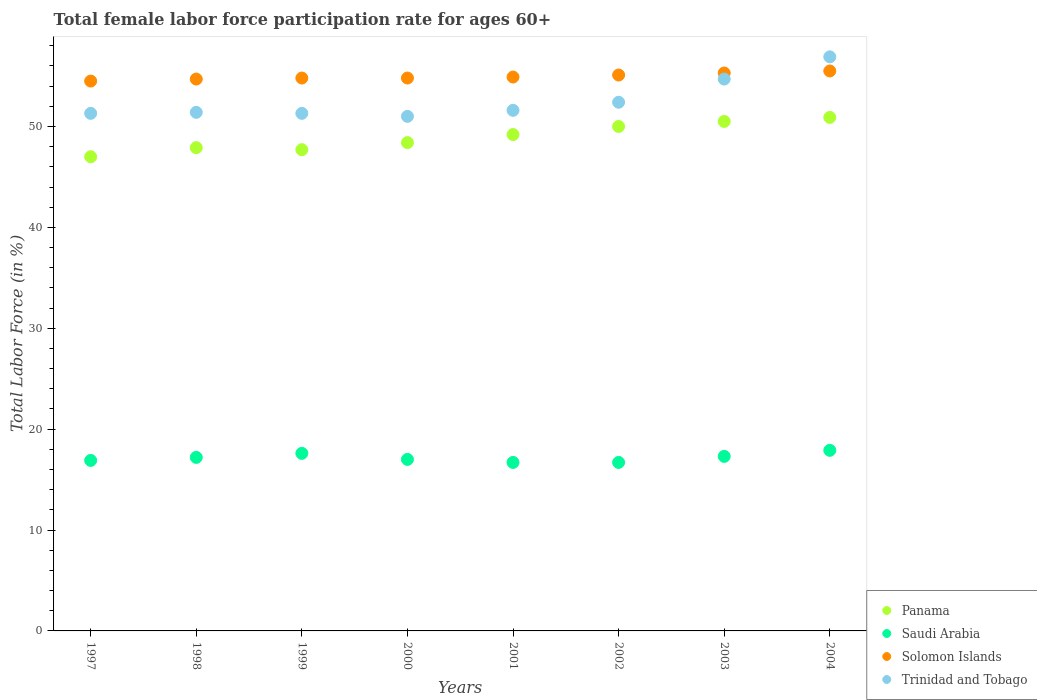Is the number of dotlines equal to the number of legend labels?
Your answer should be compact. Yes. What is the female labor force participation rate in Trinidad and Tobago in 1998?
Your response must be concise. 51.4. Across all years, what is the maximum female labor force participation rate in Saudi Arabia?
Give a very brief answer. 17.9. Across all years, what is the minimum female labor force participation rate in Panama?
Provide a succinct answer. 47. In which year was the female labor force participation rate in Trinidad and Tobago maximum?
Offer a terse response. 2004. What is the total female labor force participation rate in Solomon Islands in the graph?
Make the answer very short. 439.6. What is the difference between the female labor force participation rate in Saudi Arabia in 1999 and that in 2000?
Keep it short and to the point. 0.6. What is the difference between the female labor force participation rate in Panama in 2002 and the female labor force participation rate in Trinidad and Tobago in 1999?
Your answer should be very brief. -1.3. What is the average female labor force participation rate in Saudi Arabia per year?
Give a very brief answer. 17.16. In the year 2002, what is the difference between the female labor force participation rate in Trinidad and Tobago and female labor force participation rate in Solomon Islands?
Your answer should be compact. -2.7. In how many years, is the female labor force participation rate in Saudi Arabia greater than 54 %?
Offer a very short reply. 0. What is the ratio of the female labor force participation rate in Solomon Islands in 1999 to that in 2004?
Your answer should be very brief. 0.99. Is the female labor force participation rate in Panama in 2000 less than that in 2003?
Your answer should be very brief. Yes. Is the difference between the female labor force participation rate in Trinidad and Tobago in 2001 and 2004 greater than the difference between the female labor force participation rate in Solomon Islands in 2001 and 2004?
Make the answer very short. No. What is the difference between the highest and the second highest female labor force participation rate in Saudi Arabia?
Offer a very short reply. 0.3. What is the difference between the highest and the lowest female labor force participation rate in Panama?
Your answer should be very brief. 3.9. In how many years, is the female labor force participation rate in Panama greater than the average female labor force participation rate in Panama taken over all years?
Ensure brevity in your answer.  4. Is the sum of the female labor force participation rate in Trinidad and Tobago in 1999 and 2002 greater than the maximum female labor force participation rate in Solomon Islands across all years?
Offer a very short reply. Yes. Is it the case that in every year, the sum of the female labor force participation rate in Panama and female labor force participation rate in Saudi Arabia  is greater than the sum of female labor force participation rate in Solomon Islands and female labor force participation rate in Trinidad and Tobago?
Offer a terse response. No. Does the female labor force participation rate in Solomon Islands monotonically increase over the years?
Ensure brevity in your answer.  No. Is the female labor force participation rate in Trinidad and Tobago strictly less than the female labor force participation rate in Panama over the years?
Provide a short and direct response. No. What is the difference between two consecutive major ticks on the Y-axis?
Your answer should be very brief. 10. Are the values on the major ticks of Y-axis written in scientific E-notation?
Provide a short and direct response. No. Does the graph contain any zero values?
Provide a succinct answer. No. Does the graph contain grids?
Your answer should be compact. No. How many legend labels are there?
Provide a succinct answer. 4. What is the title of the graph?
Give a very brief answer. Total female labor force participation rate for ages 60+. What is the Total Labor Force (in %) in Panama in 1997?
Provide a short and direct response. 47. What is the Total Labor Force (in %) in Saudi Arabia in 1997?
Keep it short and to the point. 16.9. What is the Total Labor Force (in %) of Solomon Islands in 1997?
Your answer should be compact. 54.5. What is the Total Labor Force (in %) in Trinidad and Tobago in 1997?
Provide a succinct answer. 51.3. What is the Total Labor Force (in %) in Panama in 1998?
Your answer should be very brief. 47.9. What is the Total Labor Force (in %) of Saudi Arabia in 1998?
Make the answer very short. 17.2. What is the Total Labor Force (in %) of Solomon Islands in 1998?
Offer a terse response. 54.7. What is the Total Labor Force (in %) in Trinidad and Tobago in 1998?
Your answer should be very brief. 51.4. What is the Total Labor Force (in %) of Panama in 1999?
Ensure brevity in your answer.  47.7. What is the Total Labor Force (in %) of Saudi Arabia in 1999?
Ensure brevity in your answer.  17.6. What is the Total Labor Force (in %) of Solomon Islands in 1999?
Keep it short and to the point. 54.8. What is the Total Labor Force (in %) in Trinidad and Tobago in 1999?
Offer a very short reply. 51.3. What is the Total Labor Force (in %) of Panama in 2000?
Offer a terse response. 48.4. What is the Total Labor Force (in %) of Solomon Islands in 2000?
Your answer should be very brief. 54.8. What is the Total Labor Force (in %) in Trinidad and Tobago in 2000?
Provide a succinct answer. 51. What is the Total Labor Force (in %) of Panama in 2001?
Make the answer very short. 49.2. What is the Total Labor Force (in %) of Saudi Arabia in 2001?
Offer a terse response. 16.7. What is the Total Labor Force (in %) in Solomon Islands in 2001?
Ensure brevity in your answer.  54.9. What is the Total Labor Force (in %) of Trinidad and Tobago in 2001?
Your response must be concise. 51.6. What is the Total Labor Force (in %) of Panama in 2002?
Offer a very short reply. 50. What is the Total Labor Force (in %) of Saudi Arabia in 2002?
Keep it short and to the point. 16.7. What is the Total Labor Force (in %) in Solomon Islands in 2002?
Make the answer very short. 55.1. What is the Total Labor Force (in %) of Trinidad and Tobago in 2002?
Your answer should be very brief. 52.4. What is the Total Labor Force (in %) of Panama in 2003?
Your answer should be compact. 50.5. What is the Total Labor Force (in %) in Saudi Arabia in 2003?
Give a very brief answer. 17.3. What is the Total Labor Force (in %) in Solomon Islands in 2003?
Your answer should be very brief. 55.3. What is the Total Labor Force (in %) in Trinidad and Tobago in 2003?
Your answer should be compact. 54.7. What is the Total Labor Force (in %) in Panama in 2004?
Give a very brief answer. 50.9. What is the Total Labor Force (in %) of Saudi Arabia in 2004?
Offer a very short reply. 17.9. What is the Total Labor Force (in %) in Solomon Islands in 2004?
Your answer should be very brief. 55.5. What is the Total Labor Force (in %) of Trinidad and Tobago in 2004?
Provide a short and direct response. 56.9. Across all years, what is the maximum Total Labor Force (in %) of Panama?
Give a very brief answer. 50.9. Across all years, what is the maximum Total Labor Force (in %) in Saudi Arabia?
Your response must be concise. 17.9. Across all years, what is the maximum Total Labor Force (in %) of Solomon Islands?
Your answer should be compact. 55.5. Across all years, what is the maximum Total Labor Force (in %) of Trinidad and Tobago?
Your answer should be compact. 56.9. Across all years, what is the minimum Total Labor Force (in %) in Panama?
Offer a very short reply. 47. Across all years, what is the minimum Total Labor Force (in %) in Saudi Arabia?
Your answer should be very brief. 16.7. Across all years, what is the minimum Total Labor Force (in %) in Solomon Islands?
Provide a succinct answer. 54.5. Across all years, what is the minimum Total Labor Force (in %) in Trinidad and Tobago?
Provide a succinct answer. 51. What is the total Total Labor Force (in %) of Panama in the graph?
Ensure brevity in your answer.  391.6. What is the total Total Labor Force (in %) in Saudi Arabia in the graph?
Your answer should be very brief. 137.3. What is the total Total Labor Force (in %) of Solomon Islands in the graph?
Your response must be concise. 439.6. What is the total Total Labor Force (in %) of Trinidad and Tobago in the graph?
Your response must be concise. 420.6. What is the difference between the Total Labor Force (in %) of Trinidad and Tobago in 1997 and that in 1998?
Ensure brevity in your answer.  -0.1. What is the difference between the Total Labor Force (in %) in Solomon Islands in 1997 and that in 1999?
Make the answer very short. -0.3. What is the difference between the Total Labor Force (in %) of Trinidad and Tobago in 1997 and that in 1999?
Provide a short and direct response. 0. What is the difference between the Total Labor Force (in %) of Solomon Islands in 1997 and that in 2000?
Give a very brief answer. -0.3. What is the difference between the Total Labor Force (in %) of Trinidad and Tobago in 1997 and that in 2000?
Your answer should be very brief. 0.3. What is the difference between the Total Labor Force (in %) in Saudi Arabia in 1997 and that in 2001?
Your answer should be compact. 0.2. What is the difference between the Total Labor Force (in %) of Solomon Islands in 1997 and that in 2001?
Ensure brevity in your answer.  -0.4. What is the difference between the Total Labor Force (in %) in Trinidad and Tobago in 1997 and that in 2001?
Give a very brief answer. -0.3. What is the difference between the Total Labor Force (in %) of Panama in 1997 and that in 2002?
Keep it short and to the point. -3. What is the difference between the Total Labor Force (in %) of Saudi Arabia in 1997 and that in 2002?
Provide a succinct answer. 0.2. What is the difference between the Total Labor Force (in %) of Solomon Islands in 1997 and that in 2002?
Make the answer very short. -0.6. What is the difference between the Total Labor Force (in %) of Solomon Islands in 1997 and that in 2003?
Ensure brevity in your answer.  -0.8. What is the difference between the Total Labor Force (in %) of Trinidad and Tobago in 1997 and that in 2003?
Your response must be concise. -3.4. What is the difference between the Total Labor Force (in %) of Panama in 1997 and that in 2004?
Keep it short and to the point. -3.9. What is the difference between the Total Labor Force (in %) in Saudi Arabia in 1997 and that in 2004?
Provide a succinct answer. -1. What is the difference between the Total Labor Force (in %) of Solomon Islands in 1997 and that in 2004?
Give a very brief answer. -1. What is the difference between the Total Labor Force (in %) in Panama in 1998 and that in 1999?
Make the answer very short. 0.2. What is the difference between the Total Labor Force (in %) in Panama in 1998 and that in 2000?
Keep it short and to the point. -0.5. What is the difference between the Total Labor Force (in %) of Saudi Arabia in 1998 and that in 2000?
Your response must be concise. 0.2. What is the difference between the Total Labor Force (in %) of Trinidad and Tobago in 1998 and that in 2000?
Offer a very short reply. 0.4. What is the difference between the Total Labor Force (in %) in Saudi Arabia in 1998 and that in 2001?
Your response must be concise. 0.5. What is the difference between the Total Labor Force (in %) of Solomon Islands in 1998 and that in 2001?
Your answer should be very brief. -0.2. What is the difference between the Total Labor Force (in %) of Trinidad and Tobago in 1998 and that in 2001?
Offer a terse response. -0.2. What is the difference between the Total Labor Force (in %) of Solomon Islands in 1998 and that in 2002?
Your answer should be compact. -0.4. What is the difference between the Total Labor Force (in %) of Trinidad and Tobago in 1998 and that in 2002?
Ensure brevity in your answer.  -1. What is the difference between the Total Labor Force (in %) of Saudi Arabia in 1998 and that in 2003?
Provide a succinct answer. -0.1. What is the difference between the Total Labor Force (in %) in Solomon Islands in 1998 and that in 2003?
Your response must be concise. -0.6. What is the difference between the Total Labor Force (in %) in Panama in 1998 and that in 2004?
Offer a terse response. -3. What is the difference between the Total Labor Force (in %) of Saudi Arabia in 1998 and that in 2004?
Offer a terse response. -0.7. What is the difference between the Total Labor Force (in %) in Trinidad and Tobago in 1998 and that in 2004?
Offer a very short reply. -5.5. What is the difference between the Total Labor Force (in %) in Solomon Islands in 1999 and that in 2000?
Provide a succinct answer. 0. What is the difference between the Total Labor Force (in %) of Trinidad and Tobago in 1999 and that in 2000?
Your answer should be compact. 0.3. What is the difference between the Total Labor Force (in %) of Panama in 1999 and that in 2001?
Provide a short and direct response. -1.5. What is the difference between the Total Labor Force (in %) in Saudi Arabia in 1999 and that in 2001?
Ensure brevity in your answer.  0.9. What is the difference between the Total Labor Force (in %) of Solomon Islands in 1999 and that in 2001?
Give a very brief answer. -0.1. What is the difference between the Total Labor Force (in %) in Solomon Islands in 1999 and that in 2002?
Offer a terse response. -0.3. What is the difference between the Total Labor Force (in %) in Trinidad and Tobago in 1999 and that in 2002?
Keep it short and to the point. -1.1. What is the difference between the Total Labor Force (in %) of Solomon Islands in 1999 and that in 2004?
Your answer should be compact. -0.7. What is the difference between the Total Labor Force (in %) of Panama in 2000 and that in 2001?
Make the answer very short. -0.8. What is the difference between the Total Labor Force (in %) of Saudi Arabia in 2000 and that in 2001?
Keep it short and to the point. 0.3. What is the difference between the Total Labor Force (in %) of Solomon Islands in 2000 and that in 2001?
Give a very brief answer. -0.1. What is the difference between the Total Labor Force (in %) in Trinidad and Tobago in 2000 and that in 2001?
Your answer should be compact. -0.6. What is the difference between the Total Labor Force (in %) of Saudi Arabia in 2000 and that in 2002?
Offer a terse response. 0.3. What is the difference between the Total Labor Force (in %) in Solomon Islands in 2000 and that in 2002?
Ensure brevity in your answer.  -0.3. What is the difference between the Total Labor Force (in %) of Panama in 2000 and that in 2004?
Offer a terse response. -2.5. What is the difference between the Total Labor Force (in %) in Saudi Arabia in 2000 and that in 2004?
Your answer should be compact. -0.9. What is the difference between the Total Labor Force (in %) in Solomon Islands in 2000 and that in 2004?
Offer a very short reply. -0.7. What is the difference between the Total Labor Force (in %) of Trinidad and Tobago in 2000 and that in 2004?
Make the answer very short. -5.9. What is the difference between the Total Labor Force (in %) of Panama in 2001 and that in 2003?
Offer a very short reply. -1.3. What is the difference between the Total Labor Force (in %) in Panama in 2001 and that in 2004?
Your answer should be very brief. -1.7. What is the difference between the Total Labor Force (in %) of Saudi Arabia in 2001 and that in 2004?
Your response must be concise. -1.2. What is the difference between the Total Labor Force (in %) in Trinidad and Tobago in 2001 and that in 2004?
Provide a short and direct response. -5.3. What is the difference between the Total Labor Force (in %) of Saudi Arabia in 2002 and that in 2003?
Provide a succinct answer. -0.6. What is the difference between the Total Labor Force (in %) in Solomon Islands in 2002 and that in 2003?
Offer a terse response. -0.2. What is the difference between the Total Labor Force (in %) in Trinidad and Tobago in 2002 and that in 2003?
Your answer should be compact. -2.3. What is the difference between the Total Labor Force (in %) in Panama in 2002 and that in 2004?
Your answer should be compact. -0.9. What is the difference between the Total Labor Force (in %) in Saudi Arabia in 2002 and that in 2004?
Provide a short and direct response. -1.2. What is the difference between the Total Labor Force (in %) in Trinidad and Tobago in 2002 and that in 2004?
Your response must be concise. -4.5. What is the difference between the Total Labor Force (in %) in Saudi Arabia in 2003 and that in 2004?
Provide a short and direct response. -0.6. What is the difference between the Total Labor Force (in %) in Panama in 1997 and the Total Labor Force (in %) in Saudi Arabia in 1998?
Keep it short and to the point. 29.8. What is the difference between the Total Labor Force (in %) of Saudi Arabia in 1997 and the Total Labor Force (in %) of Solomon Islands in 1998?
Your answer should be compact. -37.8. What is the difference between the Total Labor Force (in %) in Saudi Arabia in 1997 and the Total Labor Force (in %) in Trinidad and Tobago in 1998?
Provide a short and direct response. -34.5. What is the difference between the Total Labor Force (in %) of Panama in 1997 and the Total Labor Force (in %) of Saudi Arabia in 1999?
Offer a very short reply. 29.4. What is the difference between the Total Labor Force (in %) of Saudi Arabia in 1997 and the Total Labor Force (in %) of Solomon Islands in 1999?
Your response must be concise. -37.9. What is the difference between the Total Labor Force (in %) in Saudi Arabia in 1997 and the Total Labor Force (in %) in Trinidad and Tobago in 1999?
Ensure brevity in your answer.  -34.4. What is the difference between the Total Labor Force (in %) in Solomon Islands in 1997 and the Total Labor Force (in %) in Trinidad and Tobago in 1999?
Offer a terse response. 3.2. What is the difference between the Total Labor Force (in %) of Panama in 1997 and the Total Labor Force (in %) of Solomon Islands in 2000?
Ensure brevity in your answer.  -7.8. What is the difference between the Total Labor Force (in %) of Saudi Arabia in 1997 and the Total Labor Force (in %) of Solomon Islands in 2000?
Ensure brevity in your answer.  -37.9. What is the difference between the Total Labor Force (in %) in Saudi Arabia in 1997 and the Total Labor Force (in %) in Trinidad and Tobago in 2000?
Your response must be concise. -34.1. What is the difference between the Total Labor Force (in %) of Solomon Islands in 1997 and the Total Labor Force (in %) of Trinidad and Tobago in 2000?
Give a very brief answer. 3.5. What is the difference between the Total Labor Force (in %) of Panama in 1997 and the Total Labor Force (in %) of Saudi Arabia in 2001?
Offer a terse response. 30.3. What is the difference between the Total Labor Force (in %) of Panama in 1997 and the Total Labor Force (in %) of Trinidad and Tobago in 2001?
Offer a very short reply. -4.6. What is the difference between the Total Labor Force (in %) in Saudi Arabia in 1997 and the Total Labor Force (in %) in Solomon Islands in 2001?
Offer a terse response. -38. What is the difference between the Total Labor Force (in %) of Saudi Arabia in 1997 and the Total Labor Force (in %) of Trinidad and Tobago in 2001?
Make the answer very short. -34.7. What is the difference between the Total Labor Force (in %) of Panama in 1997 and the Total Labor Force (in %) of Saudi Arabia in 2002?
Offer a very short reply. 30.3. What is the difference between the Total Labor Force (in %) in Panama in 1997 and the Total Labor Force (in %) in Solomon Islands in 2002?
Your answer should be very brief. -8.1. What is the difference between the Total Labor Force (in %) of Saudi Arabia in 1997 and the Total Labor Force (in %) of Solomon Islands in 2002?
Offer a very short reply. -38.2. What is the difference between the Total Labor Force (in %) in Saudi Arabia in 1997 and the Total Labor Force (in %) in Trinidad and Tobago in 2002?
Your response must be concise. -35.5. What is the difference between the Total Labor Force (in %) in Panama in 1997 and the Total Labor Force (in %) in Saudi Arabia in 2003?
Offer a terse response. 29.7. What is the difference between the Total Labor Force (in %) of Panama in 1997 and the Total Labor Force (in %) of Solomon Islands in 2003?
Your response must be concise. -8.3. What is the difference between the Total Labor Force (in %) of Saudi Arabia in 1997 and the Total Labor Force (in %) of Solomon Islands in 2003?
Your answer should be very brief. -38.4. What is the difference between the Total Labor Force (in %) of Saudi Arabia in 1997 and the Total Labor Force (in %) of Trinidad and Tobago in 2003?
Your response must be concise. -37.8. What is the difference between the Total Labor Force (in %) in Panama in 1997 and the Total Labor Force (in %) in Saudi Arabia in 2004?
Your answer should be very brief. 29.1. What is the difference between the Total Labor Force (in %) of Saudi Arabia in 1997 and the Total Labor Force (in %) of Solomon Islands in 2004?
Provide a short and direct response. -38.6. What is the difference between the Total Labor Force (in %) of Saudi Arabia in 1997 and the Total Labor Force (in %) of Trinidad and Tobago in 2004?
Make the answer very short. -40. What is the difference between the Total Labor Force (in %) of Panama in 1998 and the Total Labor Force (in %) of Saudi Arabia in 1999?
Give a very brief answer. 30.3. What is the difference between the Total Labor Force (in %) of Saudi Arabia in 1998 and the Total Labor Force (in %) of Solomon Islands in 1999?
Your answer should be very brief. -37.6. What is the difference between the Total Labor Force (in %) in Saudi Arabia in 1998 and the Total Labor Force (in %) in Trinidad and Tobago in 1999?
Make the answer very short. -34.1. What is the difference between the Total Labor Force (in %) in Solomon Islands in 1998 and the Total Labor Force (in %) in Trinidad and Tobago in 1999?
Ensure brevity in your answer.  3.4. What is the difference between the Total Labor Force (in %) in Panama in 1998 and the Total Labor Force (in %) in Saudi Arabia in 2000?
Make the answer very short. 30.9. What is the difference between the Total Labor Force (in %) in Panama in 1998 and the Total Labor Force (in %) in Trinidad and Tobago in 2000?
Make the answer very short. -3.1. What is the difference between the Total Labor Force (in %) in Saudi Arabia in 1998 and the Total Labor Force (in %) in Solomon Islands in 2000?
Offer a very short reply. -37.6. What is the difference between the Total Labor Force (in %) in Saudi Arabia in 1998 and the Total Labor Force (in %) in Trinidad and Tobago in 2000?
Your answer should be very brief. -33.8. What is the difference between the Total Labor Force (in %) of Solomon Islands in 1998 and the Total Labor Force (in %) of Trinidad and Tobago in 2000?
Provide a short and direct response. 3.7. What is the difference between the Total Labor Force (in %) of Panama in 1998 and the Total Labor Force (in %) of Saudi Arabia in 2001?
Offer a very short reply. 31.2. What is the difference between the Total Labor Force (in %) in Panama in 1998 and the Total Labor Force (in %) in Solomon Islands in 2001?
Ensure brevity in your answer.  -7. What is the difference between the Total Labor Force (in %) in Panama in 1998 and the Total Labor Force (in %) in Trinidad and Tobago in 2001?
Keep it short and to the point. -3.7. What is the difference between the Total Labor Force (in %) of Saudi Arabia in 1998 and the Total Labor Force (in %) of Solomon Islands in 2001?
Make the answer very short. -37.7. What is the difference between the Total Labor Force (in %) in Saudi Arabia in 1998 and the Total Labor Force (in %) in Trinidad and Tobago in 2001?
Ensure brevity in your answer.  -34.4. What is the difference between the Total Labor Force (in %) of Panama in 1998 and the Total Labor Force (in %) of Saudi Arabia in 2002?
Provide a short and direct response. 31.2. What is the difference between the Total Labor Force (in %) of Saudi Arabia in 1998 and the Total Labor Force (in %) of Solomon Islands in 2002?
Your answer should be very brief. -37.9. What is the difference between the Total Labor Force (in %) of Saudi Arabia in 1998 and the Total Labor Force (in %) of Trinidad and Tobago in 2002?
Make the answer very short. -35.2. What is the difference between the Total Labor Force (in %) in Solomon Islands in 1998 and the Total Labor Force (in %) in Trinidad and Tobago in 2002?
Offer a terse response. 2.3. What is the difference between the Total Labor Force (in %) in Panama in 1998 and the Total Labor Force (in %) in Saudi Arabia in 2003?
Provide a short and direct response. 30.6. What is the difference between the Total Labor Force (in %) of Panama in 1998 and the Total Labor Force (in %) of Solomon Islands in 2003?
Offer a terse response. -7.4. What is the difference between the Total Labor Force (in %) in Saudi Arabia in 1998 and the Total Labor Force (in %) in Solomon Islands in 2003?
Your answer should be compact. -38.1. What is the difference between the Total Labor Force (in %) in Saudi Arabia in 1998 and the Total Labor Force (in %) in Trinidad and Tobago in 2003?
Give a very brief answer. -37.5. What is the difference between the Total Labor Force (in %) in Solomon Islands in 1998 and the Total Labor Force (in %) in Trinidad and Tobago in 2003?
Your answer should be very brief. 0. What is the difference between the Total Labor Force (in %) of Panama in 1998 and the Total Labor Force (in %) of Trinidad and Tobago in 2004?
Keep it short and to the point. -9. What is the difference between the Total Labor Force (in %) of Saudi Arabia in 1998 and the Total Labor Force (in %) of Solomon Islands in 2004?
Offer a terse response. -38.3. What is the difference between the Total Labor Force (in %) of Saudi Arabia in 1998 and the Total Labor Force (in %) of Trinidad and Tobago in 2004?
Offer a very short reply. -39.7. What is the difference between the Total Labor Force (in %) in Panama in 1999 and the Total Labor Force (in %) in Saudi Arabia in 2000?
Offer a terse response. 30.7. What is the difference between the Total Labor Force (in %) in Panama in 1999 and the Total Labor Force (in %) in Solomon Islands in 2000?
Provide a succinct answer. -7.1. What is the difference between the Total Labor Force (in %) in Panama in 1999 and the Total Labor Force (in %) in Trinidad and Tobago in 2000?
Make the answer very short. -3.3. What is the difference between the Total Labor Force (in %) in Saudi Arabia in 1999 and the Total Labor Force (in %) in Solomon Islands in 2000?
Provide a short and direct response. -37.2. What is the difference between the Total Labor Force (in %) of Saudi Arabia in 1999 and the Total Labor Force (in %) of Trinidad and Tobago in 2000?
Keep it short and to the point. -33.4. What is the difference between the Total Labor Force (in %) of Solomon Islands in 1999 and the Total Labor Force (in %) of Trinidad and Tobago in 2000?
Provide a succinct answer. 3.8. What is the difference between the Total Labor Force (in %) in Panama in 1999 and the Total Labor Force (in %) in Saudi Arabia in 2001?
Ensure brevity in your answer.  31. What is the difference between the Total Labor Force (in %) of Saudi Arabia in 1999 and the Total Labor Force (in %) of Solomon Islands in 2001?
Offer a terse response. -37.3. What is the difference between the Total Labor Force (in %) of Saudi Arabia in 1999 and the Total Labor Force (in %) of Trinidad and Tobago in 2001?
Make the answer very short. -34. What is the difference between the Total Labor Force (in %) of Panama in 1999 and the Total Labor Force (in %) of Saudi Arabia in 2002?
Your response must be concise. 31. What is the difference between the Total Labor Force (in %) of Saudi Arabia in 1999 and the Total Labor Force (in %) of Solomon Islands in 2002?
Ensure brevity in your answer.  -37.5. What is the difference between the Total Labor Force (in %) of Saudi Arabia in 1999 and the Total Labor Force (in %) of Trinidad and Tobago in 2002?
Ensure brevity in your answer.  -34.8. What is the difference between the Total Labor Force (in %) in Solomon Islands in 1999 and the Total Labor Force (in %) in Trinidad and Tobago in 2002?
Keep it short and to the point. 2.4. What is the difference between the Total Labor Force (in %) in Panama in 1999 and the Total Labor Force (in %) in Saudi Arabia in 2003?
Your answer should be compact. 30.4. What is the difference between the Total Labor Force (in %) of Panama in 1999 and the Total Labor Force (in %) of Solomon Islands in 2003?
Give a very brief answer. -7.6. What is the difference between the Total Labor Force (in %) in Saudi Arabia in 1999 and the Total Labor Force (in %) in Solomon Islands in 2003?
Make the answer very short. -37.7. What is the difference between the Total Labor Force (in %) of Saudi Arabia in 1999 and the Total Labor Force (in %) of Trinidad and Tobago in 2003?
Your answer should be very brief. -37.1. What is the difference between the Total Labor Force (in %) in Panama in 1999 and the Total Labor Force (in %) in Saudi Arabia in 2004?
Make the answer very short. 29.8. What is the difference between the Total Labor Force (in %) of Panama in 1999 and the Total Labor Force (in %) of Solomon Islands in 2004?
Give a very brief answer. -7.8. What is the difference between the Total Labor Force (in %) in Saudi Arabia in 1999 and the Total Labor Force (in %) in Solomon Islands in 2004?
Your answer should be very brief. -37.9. What is the difference between the Total Labor Force (in %) in Saudi Arabia in 1999 and the Total Labor Force (in %) in Trinidad and Tobago in 2004?
Keep it short and to the point. -39.3. What is the difference between the Total Labor Force (in %) in Solomon Islands in 1999 and the Total Labor Force (in %) in Trinidad and Tobago in 2004?
Your response must be concise. -2.1. What is the difference between the Total Labor Force (in %) of Panama in 2000 and the Total Labor Force (in %) of Saudi Arabia in 2001?
Keep it short and to the point. 31.7. What is the difference between the Total Labor Force (in %) of Panama in 2000 and the Total Labor Force (in %) of Trinidad and Tobago in 2001?
Make the answer very short. -3.2. What is the difference between the Total Labor Force (in %) of Saudi Arabia in 2000 and the Total Labor Force (in %) of Solomon Islands in 2001?
Offer a very short reply. -37.9. What is the difference between the Total Labor Force (in %) of Saudi Arabia in 2000 and the Total Labor Force (in %) of Trinidad and Tobago in 2001?
Keep it short and to the point. -34.6. What is the difference between the Total Labor Force (in %) in Solomon Islands in 2000 and the Total Labor Force (in %) in Trinidad and Tobago in 2001?
Your response must be concise. 3.2. What is the difference between the Total Labor Force (in %) of Panama in 2000 and the Total Labor Force (in %) of Saudi Arabia in 2002?
Offer a very short reply. 31.7. What is the difference between the Total Labor Force (in %) in Panama in 2000 and the Total Labor Force (in %) in Solomon Islands in 2002?
Provide a short and direct response. -6.7. What is the difference between the Total Labor Force (in %) in Saudi Arabia in 2000 and the Total Labor Force (in %) in Solomon Islands in 2002?
Your response must be concise. -38.1. What is the difference between the Total Labor Force (in %) in Saudi Arabia in 2000 and the Total Labor Force (in %) in Trinidad and Tobago in 2002?
Your response must be concise. -35.4. What is the difference between the Total Labor Force (in %) of Solomon Islands in 2000 and the Total Labor Force (in %) of Trinidad and Tobago in 2002?
Make the answer very short. 2.4. What is the difference between the Total Labor Force (in %) of Panama in 2000 and the Total Labor Force (in %) of Saudi Arabia in 2003?
Make the answer very short. 31.1. What is the difference between the Total Labor Force (in %) in Panama in 2000 and the Total Labor Force (in %) in Solomon Islands in 2003?
Your answer should be compact. -6.9. What is the difference between the Total Labor Force (in %) of Panama in 2000 and the Total Labor Force (in %) of Trinidad and Tobago in 2003?
Give a very brief answer. -6.3. What is the difference between the Total Labor Force (in %) in Saudi Arabia in 2000 and the Total Labor Force (in %) in Solomon Islands in 2003?
Your answer should be compact. -38.3. What is the difference between the Total Labor Force (in %) in Saudi Arabia in 2000 and the Total Labor Force (in %) in Trinidad and Tobago in 2003?
Give a very brief answer. -37.7. What is the difference between the Total Labor Force (in %) of Solomon Islands in 2000 and the Total Labor Force (in %) of Trinidad and Tobago in 2003?
Provide a short and direct response. 0.1. What is the difference between the Total Labor Force (in %) in Panama in 2000 and the Total Labor Force (in %) in Saudi Arabia in 2004?
Your answer should be compact. 30.5. What is the difference between the Total Labor Force (in %) of Panama in 2000 and the Total Labor Force (in %) of Solomon Islands in 2004?
Your answer should be very brief. -7.1. What is the difference between the Total Labor Force (in %) of Saudi Arabia in 2000 and the Total Labor Force (in %) of Solomon Islands in 2004?
Keep it short and to the point. -38.5. What is the difference between the Total Labor Force (in %) of Saudi Arabia in 2000 and the Total Labor Force (in %) of Trinidad and Tobago in 2004?
Give a very brief answer. -39.9. What is the difference between the Total Labor Force (in %) of Panama in 2001 and the Total Labor Force (in %) of Saudi Arabia in 2002?
Ensure brevity in your answer.  32.5. What is the difference between the Total Labor Force (in %) of Panama in 2001 and the Total Labor Force (in %) of Trinidad and Tobago in 2002?
Keep it short and to the point. -3.2. What is the difference between the Total Labor Force (in %) of Saudi Arabia in 2001 and the Total Labor Force (in %) of Solomon Islands in 2002?
Your answer should be very brief. -38.4. What is the difference between the Total Labor Force (in %) of Saudi Arabia in 2001 and the Total Labor Force (in %) of Trinidad and Tobago in 2002?
Your answer should be very brief. -35.7. What is the difference between the Total Labor Force (in %) of Panama in 2001 and the Total Labor Force (in %) of Saudi Arabia in 2003?
Your answer should be very brief. 31.9. What is the difference between the Total Labor Force (in %) of Panama in 2001 and the Total Labor Force (in %) of Solomon Islands in 2003?
Keep it short and to the point. -6.1. What is the difference between the Total Labor Force (in %) in Panama in 2001 and the Total Labor Force (in %) in Trinidad and Tobago in 2003?
Provide a succinct answer. -5.5. What is the difference between the Total Labor Force (in %) of Saudi Arabia in 2001 and the Total Labor Force (in %) of Solomon Islands in 2003?
Your answer should be very brief. -38.6. What is the difference between the Total Labor Force (in %) in Saudi Arabia in 2001 and the Total Labor Force (in %) in Trinidad and Tobago in 2003?
Your response must be concise. -38. What is the difference between the Total Labor Force (in %) in Panama in 2001 and the Total Labor Force (in %) in Saudi Arabia in 2004?
Your response must be concise. 31.3. What is the difference between the Total Labor Force (in %) in Panama in 2001 and the Total Labor Force (in %) in Solomon Islands in 2004?
Your answer should be compact. -6.3. What is the difference between the Total Labor Force (in %) in Panama in 2001 and the Total Labor Force (in %) in Trinidad and Tobago in 2004?
Provide a succinct answer. -7.7. What is the difference between the Total Labor Force (in %) of Saudi Arabia in 2001 and the Total Labor Force (in %) of Solomon Islands in 2004?
Offer a very short reply. -38.8. What is the difference between the Total Labor Force (in %) in Saudi Arabia in 2001 and the Total Labor Force (in %) in Trinidad and Tobago in 2004?
Your answer should be compact. -40.2. What is the difference between the Total Labor Force (in %) in Panama in 2002 and the Total Labor Force (in %) in Saudi Arabia in 2003?
Provide a succinct answer. 32.7. What is the difference between the Total Labor Force (in %) in Saudi Arabia in 2002 and the Total Labor Force (in %) in Solomon Islands in 2003?
Your answer should be very brief. -38.6. What is the difference between the Total Labor Force (in %) of Saudi Arabia in 2002 and the Total Labor Force (in %) of Trinidad and Tobago in 2003?
Provide a succinct answer. -38. What is the difference between the Total Labor Force (in %) of Solomon Islands in 2002 and the Total Labor Force (in %) of Trinidad and Tobago in 2003?
Your response must be concise. 0.4. What is the difference between the Total Labor Force (in %) of Panama in 2002 and the Total Labor Force (in %) of Saudi Arabia in 2004?
Offer a terse response. 32.1. What is the difference between the Total Labor Force (in %) of Panama in 2002 and the Total Labor Force (in %) of Trinidad and Tobago in 2004?
Provide a short and direct response. -6.9. What is the difference between the Total Labor Force (in %) of Saudi Arabia in 2002 and the Total Labor Force (in %) of Solomon Islands in 2004?
Offer a terse response. -38.8. What is the difference between the Total Labor Force (in %) of Saudi Arabia in 2002 and the Total Labor Force (in %) of Trinidad and Tobago in 2004?
Offer a terse response. -40.2. What is the difference between the Total Labor Force (in %) of Panama in 2003 and the Total Labor Force (in %) of Saudi Arabia in 2004?
Provide a succinct answer. 32.6. What is the difference between the Total Labor Force (in %) in Saudi Arabia in 2003 and the Total Labor Force (in %) in Solomon Islands in 2004?
Keep it short and to the point. -38.2. What is the difference between the Total Labor Force (in %) in Saudi Arabia in 2003 and the Total Labor Force (in %) in Trinidad and Tobago in 2004?
Give a very brief answer. -39.6. What is the average Total Labor Force (in %) in Panama per year?
Your answer should be compact. 48.95. What is the average Total Labor Force (in %) in Saudi Arabia per year?
Provide a short and direct response. 17.16. What is the average Total Labor Force (in %) of Solomon Islands per year?
Provide a short and direct response. 54.95. What is the average Total Labor Force (in %) of Trinidad and Tobago per year?
Offer a very short reply. 52.58. In the year 1997, what is the difference between the Total Labor Force (in %) of Panama and Total Labor Force (in %) of Saudi Arabia?
Your response must be concise. 30.1. In the year 1997, what is the difference between the Total Labor Force (in %) of Panama and Total Labor Force (in %) of Trinidad and Tobago?
Keep it short and to the point. -4.3. In the year 1997, what is the difference between the Total Labor Force (in %) in Saudi Arabia and Total Labor Force (in %) in Solomon Islands?
Your response must be concise. -37.6. In the year 1997, what is the difference between the Total Labor Force (in %) of Saudi Arabia and Total Labor Force (in %) of Trinidad and Tobago?
Ensure brevity in your answer.  -34.4. In the year 1998, what is the difference between the Total Labor Force (in %) in Panama and Total Labor Force (in %) in Saudi Arabia?
Ensure brevity in your answer.  30.7. In the year 1998, what is the difference between the Total Labor Force (in %) of Panama and Total Labor Force (in %) of Trinidad and Tobago?
Give a very brief answer. -3.5. In the year 1998, what is the difference between the Total Labor Force (in %) in Saudi Arabia and Total Labor Force (in %) in Solomon Islands?
Ensure brevity in your answer.  -37.5. In the year 1998, what is the difference between the Total Labor Force (in %) of Saudi Arabia and Total Labor Force (in %) of Trinidad and Tobago?
Make the answer very short. -34.2. In the year 1999, what is the difference between the Total Labor Force (in %) of Panama and Total Labor Force (in %) of Saudi Arabia?
Offer a very short reply. 30.1. In the year 1999, what is the difference between the Total Labor Force (in %) of Panama and Total Labor Force (in %) of Solomon Islands?
Ensure brevity in your answer.  -7.1. In the year 1999, what is the difference between the Total Labor Force (in %) of Panama and Total Labor Force (in %) of Trinidad and Tobago?
Your answer should be very brief. -3.6. In the year 1999, what is the difference between the Total Labor Force (in %) in Saudi Arabia and Total Labor Force (in %) in Solomon Islands?
Make the answer very short. -37.2. In the year 1999, what is the difference between the Total Labor Force (in %) of Saudi Arabia and Total Labor Force (in %) of Trinidad and Tobago?
Your answer should be very brief. -33.7. In the year 1999, what is the difference between the Total Labor Force (in %) of Solomon Islands and Total Labor Force (in %) of Trinidad and Tobago?
Make the answer very short. 3.5. In the year 2000, what is the difference between the Total Labor Force (in %) of Panama and Total Labor Force (in %) of Saudi Arabia?
Give a very brief answer. 31.4. In the year 2000, what is the difference between the Total Labor Force (in %) in Saudi Arabia and Total Labor Force (in %) in Solomon Islands?
Your response must be concise. -37.8. In the year 2000, what is the difference between the Total Labor Force (in %) of Saudi Arabia and Total Labor Force (in %) of Trinidad and Tobago?
Ensure brevity in your answer.  -34. In the year 2000, what is the difference between the Total Labor Force (in %) in Solomon Islands and Total Labor Force (in %) in Trinidad and Tobago?
Your answer should be very brief. 3.8. In the year 2001, what is the difference between the Total Labor Force (in %) of Panama and Total Labor Force (in %) of Saudi Arabia?
Offer a very short reply. 32.5. In the year 2001, what is the difference between the Total Labor Force (in %) in Saudi Arabia and Total Labor Force (in %) in Solomon Islands?
Your answer should be very brief. -38.2. In the year 2001, what is the difference between the Total Labor Force (in %) in Saudi Arabia and Total Labor Force (in %) in Trinidad and Tobago?
Give a very brief answer. -34.9. In the year 2001, what is the difference between the Total Labor Force (in %) in Solomon Islands and Total Labor Force (in %) in Trinidad and Tobago?
Keep it short and to the point. 3.3. In the year 2002, what is the difference between the Total Labor Force (in %) in Panama and Total Labor Force (in %) in Saudi Arabia?
Ensure brevity in your answer.  33.3. In the year 2002, what is the difference between the Total Labor Force (in %) of Saudi Arabia and Total Labor Force (in %) of Solomon Islands?
Give a very brief answer. -38.4. In the year 2002, what is the difference between the Total Labor Force (in %) in Saudi Arabia and Total Labor Force (in %) in Trinidad and Tobago?
Offer a very short reply. -35.7. In the year 2002, what is the difference between the Total Labor Force (in %) of Solomon Islands and Total Labor Force (in %) of Trinidad and Tobago?
Your answer should be very brief. 2.7. In the year 2003, what is the difference between the Total Labor Force (in %) of Panama and Total Labor Force (in %) of Saudi Arabia?
Make the answer very short. 33.2. In the year 2003, what is the difference between the Total Labor Force (in %) of Panama and Total Labor Force (in %) of Solomon Islands?
Provide a short and direct response. -4.8. In the year 2003, what is the difference between the Total Labor Force (in %) of Panama and Total Labor Force (in %) of Trinidad and Tobago?
Offer a terse response. -4.2. In the year 2003, what is the difference between the Total Labor Force (in %) in Saudi Arabia and Total Labor Force (in %) in Solomon Islands?
Keep it short and to the point. -38. In the year 2003, what is the difference between the Total Labor Force (in %) of Saudi Arabia and Total Labor Force (in %) of Trinidad and Tobago?
Make the answer very short. -37.4. In the year 2004, what is the difference between the Total Labor Force (in %) in Panama and Total Labor Force (in %) in Trinidad and Tobago?
Your answer should be compact. -6. In the year 2004, what is the difference between the Total Labor Force (in %) of Saudi Arabia and Total Labor Force (in %) of Solomon Islands?
Make the answer very short. -37.6. In the year 2004, what is the difference between the Total Labor Force (in %) of Saudi Arabia and Total Labor Force (in %) of Trinidad and Tobago?
Your response must be concise. -39. In the year 2004, what is the difference between the Total Labor Force (in %) in Solomon Islands and Total Labor Force (in %) in Trinidad and Tobago?
Make the answer very short. -1.4. What is the ratio of the Total Labor Force (in %) of Panama in 1997 to that in 1998?
Give a very brief answer. 0.98. What is the ratio of the Total Labor Force (in %) of Saudi Arabia in 1997 to that in 1998?
Give a very brief answer. 0.98. What is the ratio of the Total Labor Force (in %) in Solomon Islands in 1997 to that in 1998?
Ensure brevity in your answer.  1. What is the ratio of the Total Labor Force (in %) of Panama in 1997 to that in 1999?
Give a very brief answer. 0.99. What is the ratio of the Total Labor Force (in %) in Saudi Arabia in 1997 to that in 1999?
Your answer should be compact. 0.96. What is the ratio of the Total Labor Force (in %) in Solomon Islands in 1997 to that in 1999?
Your answer should be very brief. 0.99. What is the ratio of the Total Labor Force (in %) of Panama in 1997 to that in 2000?
Provide a succinct answer. 0.97. What is the ratio of the Total Labor Force (in %) of Saudi Arabia in 1997 to that in 2000?
Provide a short and direct response. 0.99. What is the ratio of the Total Labor Force (in %) of Solomon Islands in 1997 to that in 2000?
Offer a terse response. 0.99. What is the ratio of the Total Labor Force (in %) of Trinidad and Tobago in 1997 to that in 2000?
Give a very brief answer. 1.01. What is the ratio of the Total Labor Force (in %) of Panama in 1997 to that in 2001?
Keep it short and to the point. 0.96. What is the ratio of the Total Labor Force (in %) of Solomon Islands in 1997 to that in 2001?
Provide a short and direct response. 0.99. What is the ratio of the Total Labor Force (in %) of Panama in 1997 to that in 2002?
Your response must be concise. 0.94. What is the ratio of the Total Labor Force (in %) in Panama in 1997 to that in 2003?
Your answer should be compact. 0.93. What is the ratio of the Total Labor Force (in %) of Saudi Arabia in 1997 to that in 2003?
Your response must be concise. 0.98. What is the ratio of the Total Labor Force (in %) in Solomon Islands in 1997 to that in 2003?
Give a very brief answer. 0.99. What is the ratio of the Total Labor Force (in %) of Trinidad and Tobago in 1997 to that in 2003?
Ensure brevity in your answer.  0.94. What is the ratio of the Total Labor Force (in %) in Panama in 1997 to that in 2004?
Your response must be concise. 0.92. What is the ratio of the Total Labor Force (in %) of Saudi Arabia in 1997 to that in 2004?
Your response must be concise. 0.94. What is the ratio of the Total Labor Force (in %) of Trinidad and Tobago in 1997 to that in 2004?
Provide a short and direct response. 0.9. What is the ratio of the Total Labor Force (in %) in Saudi Arabia in 1998 to that in 1999?
Make the answer very short. 0.98. What is the ratio of the Total Labor Force (in %) of Solomon Islands in 1998 to that in 1999?
Ensure brevity in your answer.  1. What is the ratio of the Total Labor Force (in %) of Trinidad and Tobago in 1998 to that in 1999?
Make the answer very short. 1. What is the ratio of the Total Labor Force (in %) of Panama in 1998 to that in 2000?
Ensure brevity in your answer.  0.99. What is the ratio of the Total Labor Force (in %) in Saudi Arabia in 1998 to that in 2000?
Provide a succinct answer. 1.01. What is the ratio of the Total Labor Force (in %) of Solomon Islands in 1998 to that in 2000?
Your answer should be compact. 1. What is the ratio of the Total Labor Force (in %) of Panama in 1998 to that in 2001?
Provide a short and direct response. 0.97. What is the ratio of the Total Labor Force (in %) in Saudi Arabia in 1998 to that in 2001?
Provide a succinct answer. 1.03. What is the ratio of the Total Labor Force (in %) in Solomon Islands in 1998 to that in 2001?
Ensure brevity in your answer.  1. What is the ratio of the Total Labor Force (in %) of Trinidad and Tobago in 1998 to that in 2001?
Ensure brevity in your answer.  1. What is the ratio of the Total Labor Force (in %) in Panama in 1998 to that in 2002?
Your response must be concise. 0.96. What is the ratio of the Total Labor Force (in %) of Saudi Arabia in 1998 to that in 2002?
Keep it short and to the point. 1.03. What is the ratio of the Total Labor Force (in %) of Solomon Islands in 1998 to that in 2002?
Offer a terse response. 0.99. What is the ratio of the Total Labor Force (in %) of Trinidad and Tobago in 1998 to that in 2002?
Offer a terse response. 0.98. What is the ratio of the Total Labor Force (in %) of Panama in 1998 to that in 2003?
Your response must be concise. 0.95. What is the ratio of the Total Labor Force (in %) in Trinidad and Tobago in 1998 to that in 2003?
Ensure brevity in your answer.  0.94. What is the ratio of the Total Labor Force (in %) in Panama in 1998 to that in 2004?
Provide a succinct answer. 0.94. What is the ratio of the Total Labor Force (in %) in Saudi Arabia in 1998 to that in 2004?
Give a very brief answer. 0.96. What is the ratio of the Total Labor Force (in %) of Solomon Islands in 1998 to that in 2004?
Your answer should be compact. 0.99. What is the ratio of the Total Labor Force (in %) of Trinidad and Tobago in 1998 to that in 2004?
Make the answer very short. 0.9. What is the ratio of the Total Labor Force (in %) in Panama in 1999 to that in 2000?
Keep it short and to the point. 0.99. What is the ratio of the Total Labor Force (in %) in Saudi Arabia in 1999 to that in 2000?
Your answer should be very brief. 1.04. What is the ratio of the Total Labor Force (in %) in Trinidad and Tobago in 1999 to that in 2000?
Your response must be concise. 1.01. What is the ratio of the Total Labor Force (in %) of Panama in 1999 to that in 2001?
Your response must be concise. 0.97. What is the ratio of the Total Labor Force (in %) of Saudi Arabia in 1999 to that in 2001?
Your answer should be compact. 1.05. What is the ratio of the Total Labor Force (in %) in Solomon Islands in 1999 to that in 2001?
Keep it short and to the point. 1. What is the ratio of the Total Labor Force (in %) of Trinidad and Tobago in 1999 to that in 2001?
Offer a very short reply. 0.99. What is the ratio of the Total Labor Force (in %) of Panama in 1999 to that in 2002?
Your answer should be very brief. 0.95. What is the ratio of the Total Labor Force (in %) in Saudi Arabia in 1999 to that in 2002?
Offer a very short reply. 1.05. What is the ratio of the Total Labor Force (in %) in Solomon Islands in 1999 to that in 2002?
Provide a succinct answer. 0.99. What is the ratio of the Total Labor Force (in %) of Trinidad and Tobago in 1999 to that in 2002?
Your answer should be very brief. 0.98. What is the ratio of the Total Labor Force (in %) of Panama in 1999 to that in 2003?
Offer a terse response. 0.94. What is the ratio of the Total Labor Force (in %) of Saudi Arabia in 1999 to that in 2003?
Give a very brief answer. 1.02. What is the ratio of the Total Labor Force (in %) in Solomon Islands in 1999 to that in 2003?
Your response must be concise. 0.99. What is the ratio of the Total Labor Force (in %) of Trinidad and Tobago in 1999 to that in 2003?
Provide a succinct answer. 0.94. What is the ratio of the Total Labor Force (in %) of Panama in 1999 to that in 2004?
Offer a terse response. 0.94. What is the ratio of the Total Labor Force (in %) in Saudi Arabia in 1999 to that in 2004?
Give a very brief answer. 0.98. What is the ratio of the Total Labor Force (in %) of Solomon Islands in 1999 to that in 2004?
Offer a terse response. 0.99. What is the ratio of the Total Labor Force (in %) in Trinidad and Tobago in 1999 to that in 2004?
Offer a very short reply. 0.9. What is the ratio of the Total Labor Force (in %) in Panama in 2000 to that in 2001?
Make the answer very short. 0.98. What is the ratio of the Total Labor Force (in %) of Saudi Arabia in 2000 to that in 2001?
Provide a succinct answer. 1.02. What is the ratio of the Total Labor Force (in %) in Trinidad and Tobago in 2000 to that in 2001?
Make the answer very short. 0.99. What is the ratio of the Total Labor Force (in %) of Solomon Islands in 2000 to that in 2002?
Keep it short and to the point. 0.99. What is the ratio of the Total Labor Force (in %) of Trinidad and Tobago in 2000 to that in 2002?
Give a very brief answer. 0.97. What is the ratio of the Total Labor Force (in %) in Panama in 2000 to that in 2003?
Give a very brief answer. 0.96. What is the ratio of the Total Labor Force (in %) of Saudi Arabia in 2000 to that in 2003?
Offer a terse response. 0.98. What is the ratio of the Total Labor Force (in %) of Trinidad and Tobago in 2000 to that in 2003?
Your answer should be compact. 0.93. What is the ratio of the Total Labor Force (in %) in Panama in 2000 to that in 2004?
Keep it short and to the point. 0.95. What is the ratio of the Total Labor Force (in %) of Saudi Arabia in 2000 to that in 2004?
Keep it short and to the point. 0.95. What is the ratio of the Total Labor Force (in %) in Solomon Islands in 2000 to that in 2004?
Offer a terse response. 0.99. What is the ratio of the Total Labor Force (in %) of Trinidad and Tobago in 2000 to that in 2004?
Ensure brevity in your answer.  0.9. What is the ratio of the Total Labor Force (in %) of Panama in 2001 to that in 2002?
Offer a terse response. 0.98. What is the ratio of the Total Labor Force (in %) of Trinidad and Tobago in 2001 to that in 2002?
Your answer should be compact. 0.98. What is the ratio of the Total Labor Force (in %) of Panama in 2001 to that in 2003?
Your answer should be very brief. 0.97. What is the ratio of the Total Labor Force (in %) in Saudi Arabia in 2001 to that in 2003?
Your answer should be compact. 0.97. What is the ratio of the Total Labor Force (in %) in Trinidad and Tobago in 2001 to that in 2003?
Provide a succinct answer. 0.94. What is the ratio of the Total Labor Force (in %) in Panama in 2001 to that in 2004?
Make the answer very short. 0.97. What is the ratio of the Total Labor Force (in %) of Saudi Arabia in 2001 to that in 2004?
Offer a very short reply. 0.93. What is the ratio of the Total Labor Force (in %) in Solomon Islands in 2001 to that in 2004?
Your answer should be compact. 0.99. What is the ratio of the Total Labor Force (in %) of Trinidad and Tobago in 2001 to that in 2004?
Give a very brief answer. 0.91. What is the ratio of the Total Labor Force (in %) of Panama in 2002 to that in 2003?
Offer a terse response. 0.99. What is the ratio of the Total Labor Force (in %) of Saudi Arabia in 2002 to that in 2003?
Offer a terse response. 0.97. What is the ratio of the Total Labor Force (in %) in Solomon Islands in 2002 to that in 2003?
Provide a short and direct response. 1. What is the ratio of the Total Labor Force (in %) in Trinidad and Tobago in 2002 to that in 2003?
Your answer should be compact. 0.96. What is the ratio of the Total Labor Force (in %) in Panama in 2002 to that in 2004?
Offer a very short reply. 0.98. What is the ratio of the Total Labor Force (in %) in Saudi Arabia in 2002 to that in 2004?
Give a very brief answer. 0.93. What is the ratio of the Total Labor Force (in %) in Trinidad and Tobago in 2002 to that in 2004?
Your answer should be compact. 0.92. What is the ratio of the Total Labor Force (in %) in Panama in 2003 to that in 2004?
Provide a succinct answer. 0.99. What is the ratio of the Total Labor Force (in %) of Saudi Arabia in 2003 to that in 2004?
Give a very brief answer. 0.97. What is the ratio of the Total Labor Force (in %) of Solomon Islands in 2003 to that in 2004?
Provide a succinct answer. 1. What is the ratio of the Total Labor Force (in %) in Trinidad and Tobago in 2003 to that in 2004?
Ensure brevity in your answer.  0.96. What is the difference between the highest and the second highest Total Labor Force (in %) of Solomon Islands?
Offer a terse response. 0.2. What is the difference between the highest and the lowest Total Labor Force (in %) in Saudi Arabia?
Offer a terse response. 1.2. What is the difference between the highest and the lowest Total Labor Force (in %) in Solomon Islands?
Keep it short and to the point. 1. What is the difference between the highest and the lowest Total Labor Force (in %) of Trinidad and Tobago?
Your answer should be compact. 5.9. 